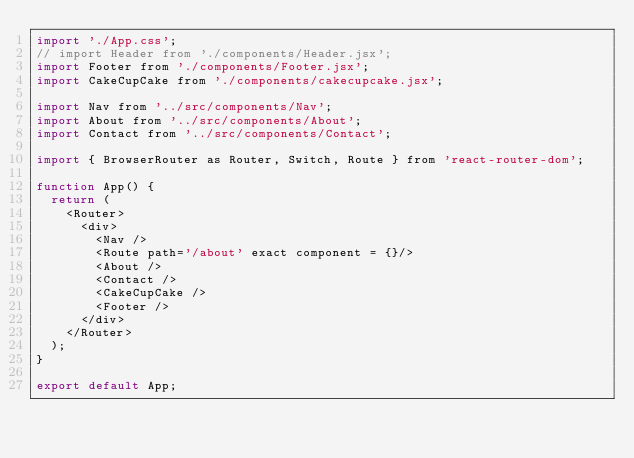<code> <loc_0><loc_0><loc_500><loc_500><_JavaScript_>import './App.css';
// import Header from './components/Header.jsx';
import Footer from './components/Footer.jsx';
import CakeCupCake from './components/cakecupcake.jsx';

import Nav from '../src/components/Nav';
import About from '../src/components/About';
import Contact from '../src/components/Contact';

import { BrowserRouter as Router, Switch, Route } from 'react-router-dom';

function App() {
  return (
    <Router>
      <div>
        <Nav />
        <Route path='/about' exact component = {}/>
        <About />
        <Contact />
        <CakeCupCake />
        <Footer />
      </div>
    </Router>
  );
}

export default App;
</code> 